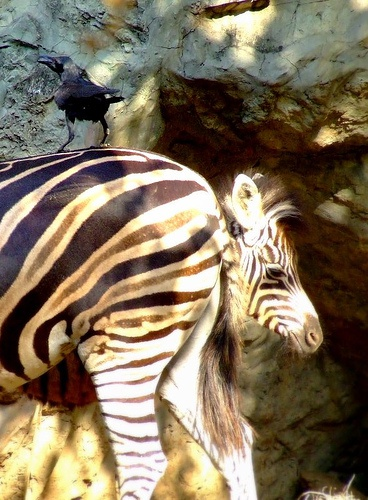Describe the objects in this image and their specific colors. I can see zebra in darkgray, ivory, black, tan, and gray tones, zebra in darkgray, ivory, khaki, tan, and gray tones, and bird in darkgray, black, gray, and navy tones in this image. 